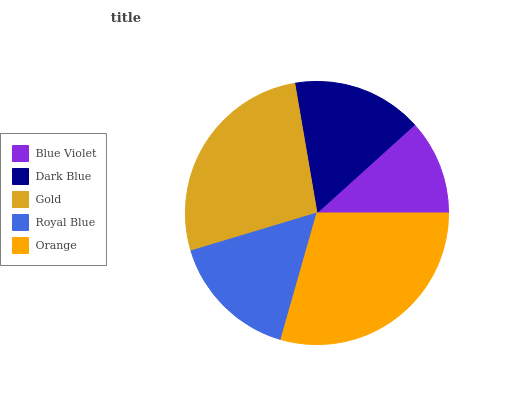Is Blue Violet the minimum?
Answer yes or no. Yes. Is Orange the maximum?
Answer yes or no. Yes. Is Dark Blue the minimum?
Answer yes or no. No. Is Dark Blue the maximum?
Answer yes or no. No. Is Dark Blue greater than Blue Violet?
Answer yes or no. Yes. Is Blue Violet less than Dark Blue?
Answer yes or no. Yes. Is Blue Violet greater than Dark Blue?
Answer yes or no. No. Is Dark Blue less than Blue Violet?
Answer yes or no. No. Is Dark Blue the high median?
Answer yes or no. Yes. Is Dark Blue the low median?
Answer yes or no. Yes. Is Royal Blue the high median?
Answer yes or no. No. Is Orange the low median?
Answer yes or no. No. 